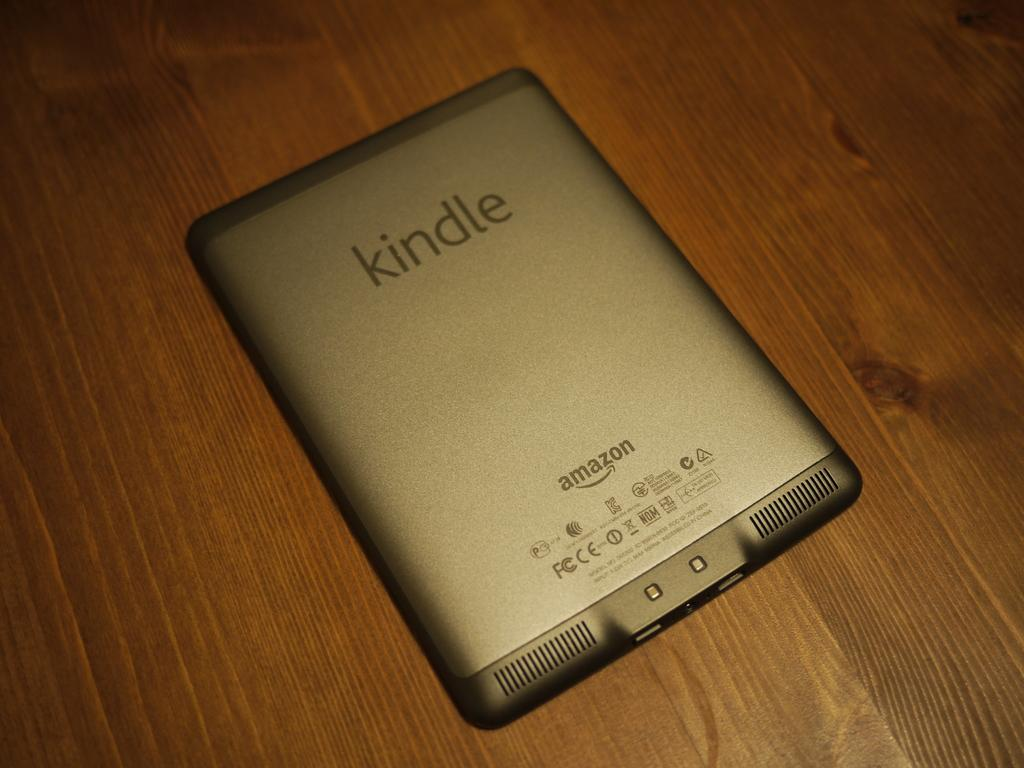<image>
Summarize the visual content of the image. A kindle is screen down on a wood surface. 